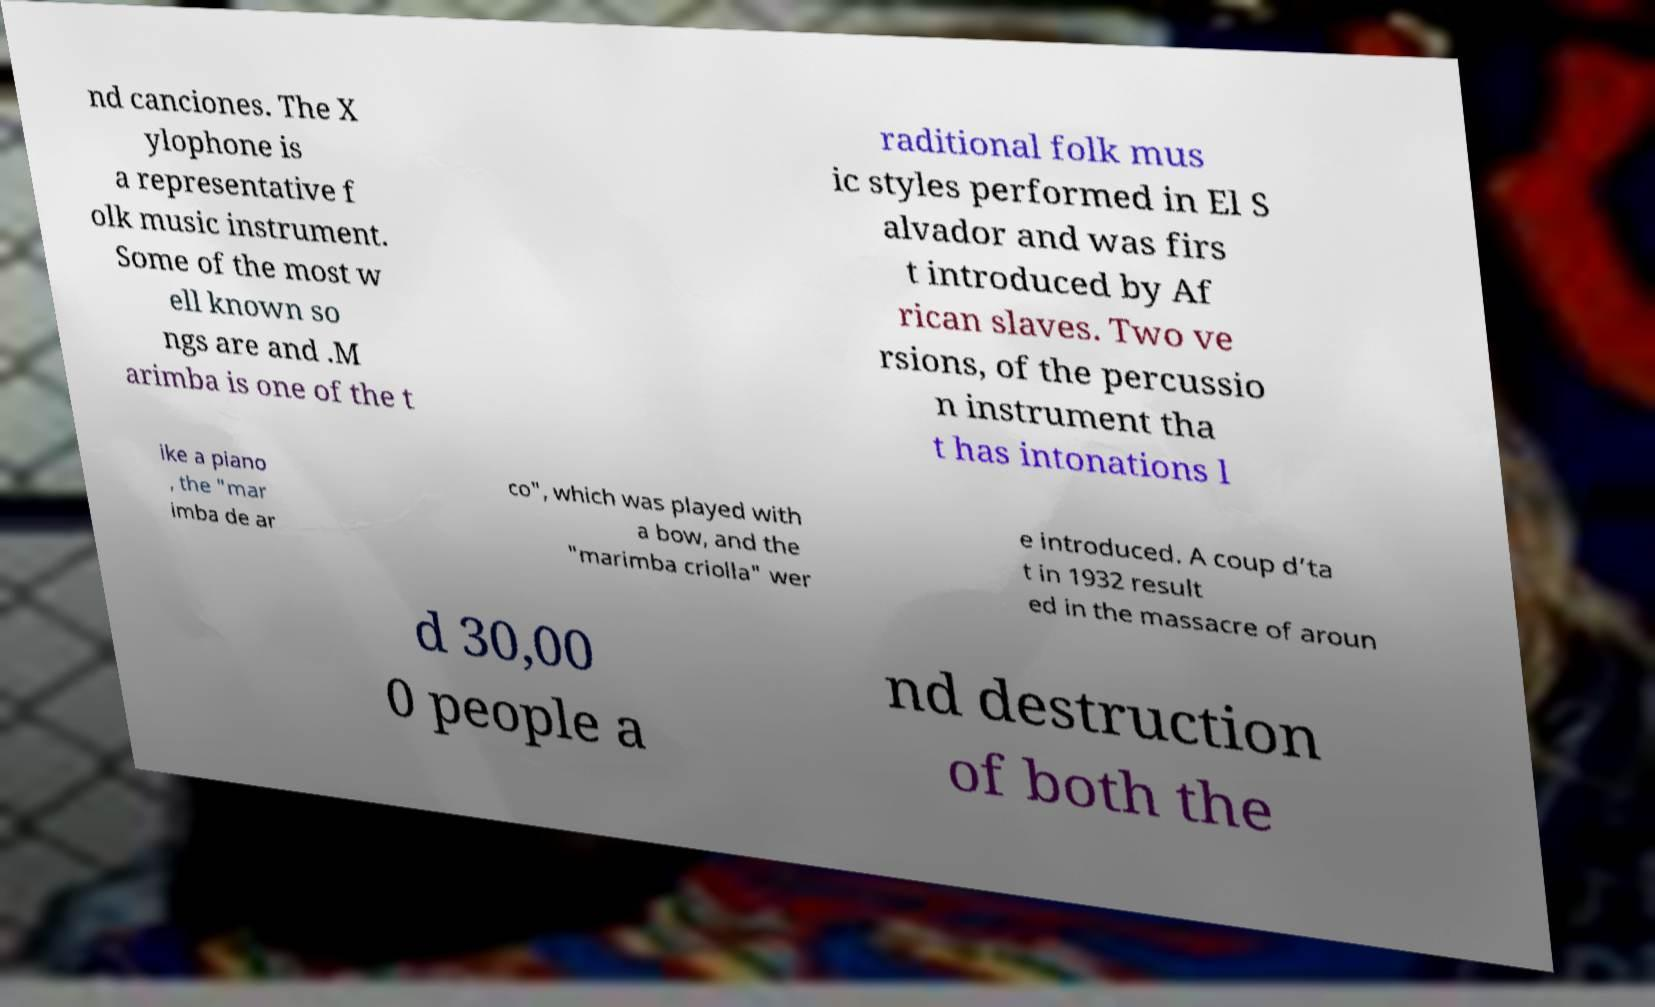For documentation purposes, I need the text within this image transcribed. Could you provide that? nd canciones. The X ylophone is a representative f olk music instrument. Some of the most w ell known so ngs are and .M arimba is one of the t raditional folk mus ic styles performed in El S alvador and was firs t introduced by Af rican slaves. Two ve rsions, of the percussio n instrument tha t has intonations l ike a piano , the "mar imba de ar co", which was played with a bow, and the "marimba criolla" wer e introduced. A coup d’ta t in 1932 result ed in the massacre of aroun d 30,00 0 people a nd destruction of both the 